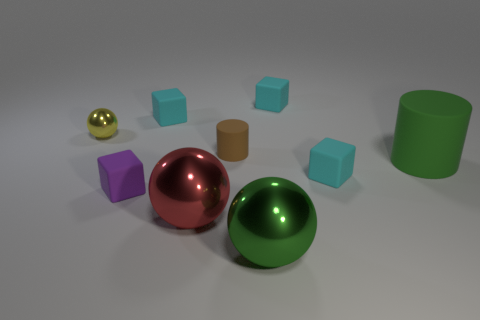What could be the function of these objects if they were part of a larger machine? If these objects were part of a larger machine, the spheres could serve as bearings or rollers, allowing for smooth movement between parts. The cylinder might act as a pivot or a shaft, while the cube shapes could form a part of a structural framework, providing stability and support to the mechanism. 